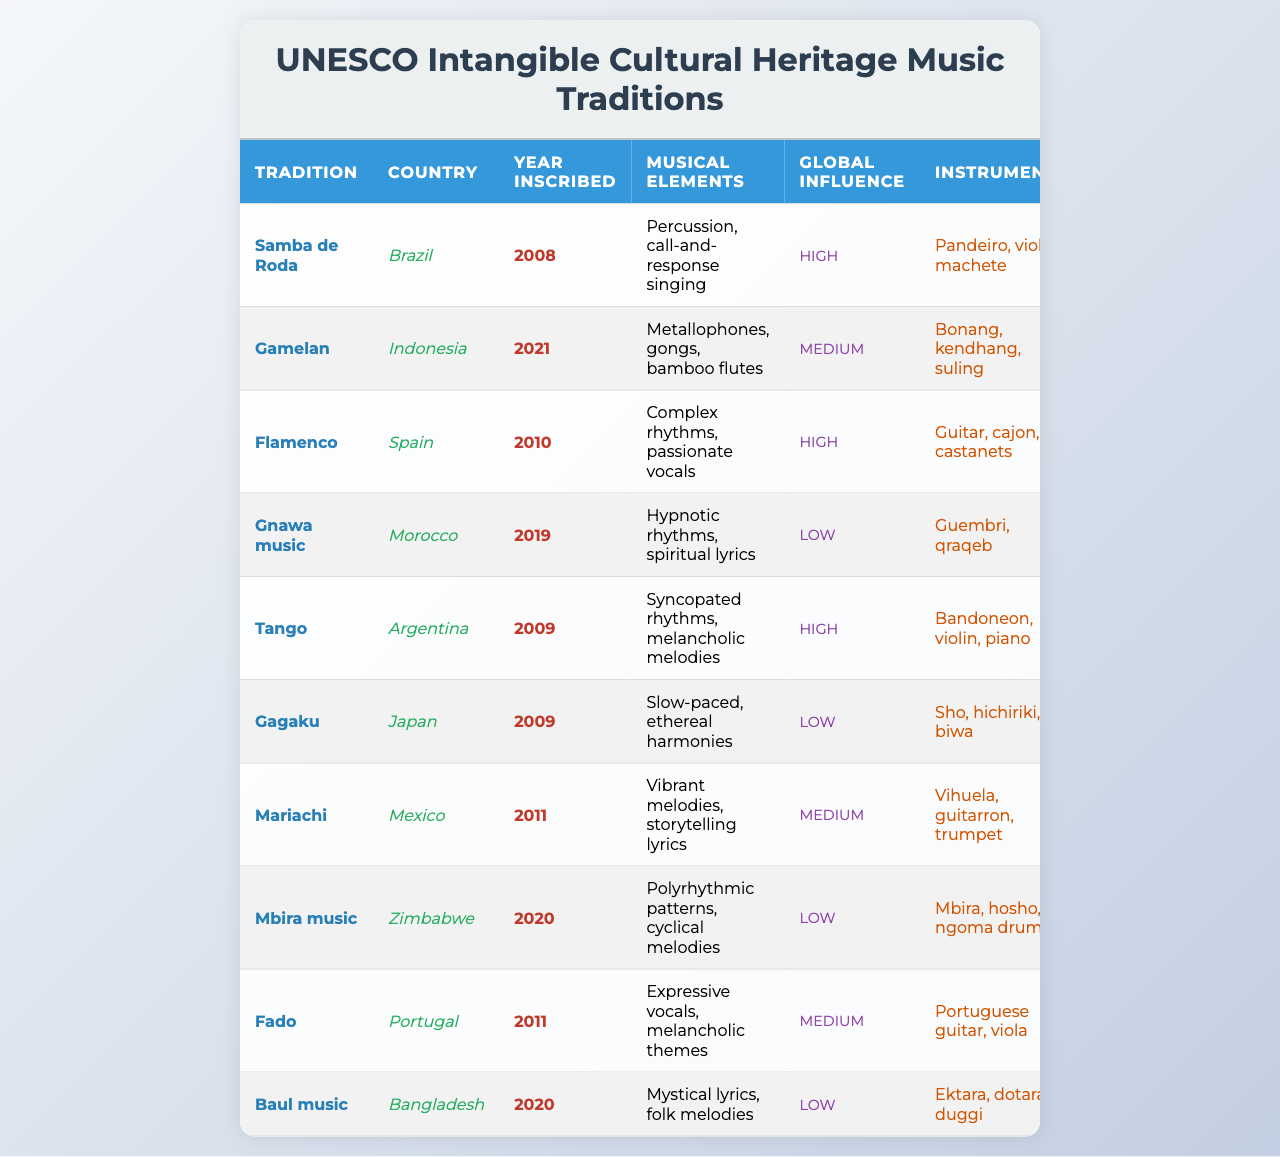What is the musical tradition from Brazil inscribed in 2008? The table lists "Samba de Roda" as the musical tradition from Brazil with a year of inscription of 2008.
Answer: Samba de Roda Which country has a music tradition inscribed in 2021? According to the table, Indonesia has a music tradition called "Gamelan" that was inscribed in 2021.
Answer: Indonesia What instruments are used in Flamenco music? The table specifies that Flamenco music uses the instruments Guitar, cajon, and castanets.
Answer: Guitar, cajon, castanets How many traditions have a high global influence? There are four traditions with a high global influence: Samba de Roda, Flamenco, Tango, and Fado.
Answer: Four Is Gnawa music from Morocco? The table confirms that Gnawa music is listed as originating from Morocco.
Answer: Yes What year was Mariachi music inscribed? According to the table, Mariachi music has the year of inscription of 2011.
Answer: 2011 Which tradition uses the instruments mbira, hosho, and ngoma drums? The table indicates that Mbira music from Zimbabwe uses these instruments.
Answer: Mbira music What is the average year of inscription for the traditions with low global influence? The years inscribed for the traditions with low global influence are 2019 (Gnawa music), 2009 (Gagaku), 2020 (Mbira music), and 2020 (Baul music). The average is (2019 + 2009 + 2020 + 2020) / 4 = 2014.5.
Answer: 2014.5 Which tradition has the most unique instruments listed? The table doesn't provide a direct count of unique instruments, but based on visual inspection, traditions like Gamelan and Mariachi have listed a combination of instruments that may appear more distinctive compared to others.
Answer: Gamelan or Mariachi Are there more music traditions from South America or Asia in the table? The table shows three traditions from South America (Samba de Roda, Tango, Mariachi) and one from Asia (Gagaku). Therefore, there are more traditions from South America.
Answer: South America 